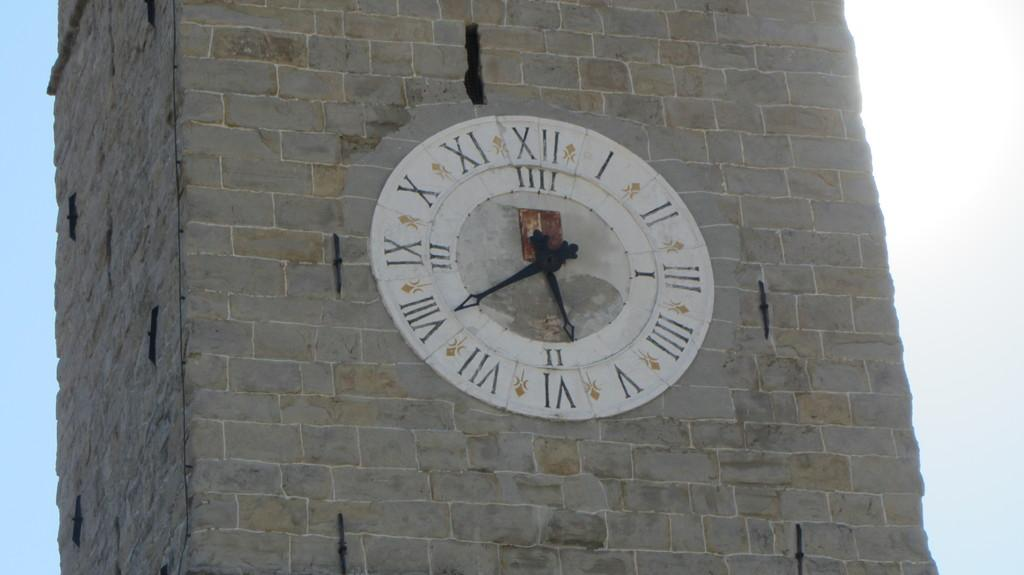What type of structure is present in the image? There is a rock wall in the image. What can be seen in the middle of the image? There is a clock in the middle of the image. What part of the natural environment is visible in the image? The sky is visible in the image. What type of soup is being served in the tent in the image? There is no soup or tent present in the image; it features a rock wall and a clock. What sound does the bell make in the image? There is no bell present in the image. 